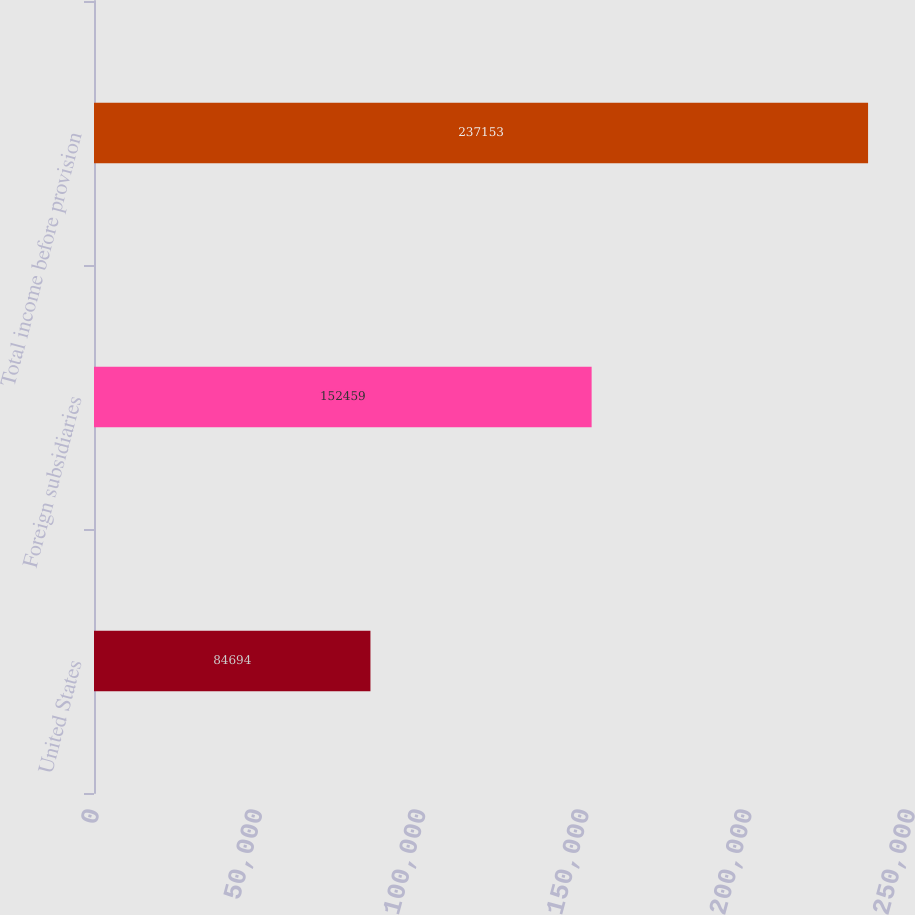<chart> <loc_0><loc_0><loc_500><loc_500><bar_chart><fcel>United States<fcel>Foreign subsidiaries<fcel>Total income before provision<nl><fcel>84694<fcel>152459<fcel>237153<nl></chart> 